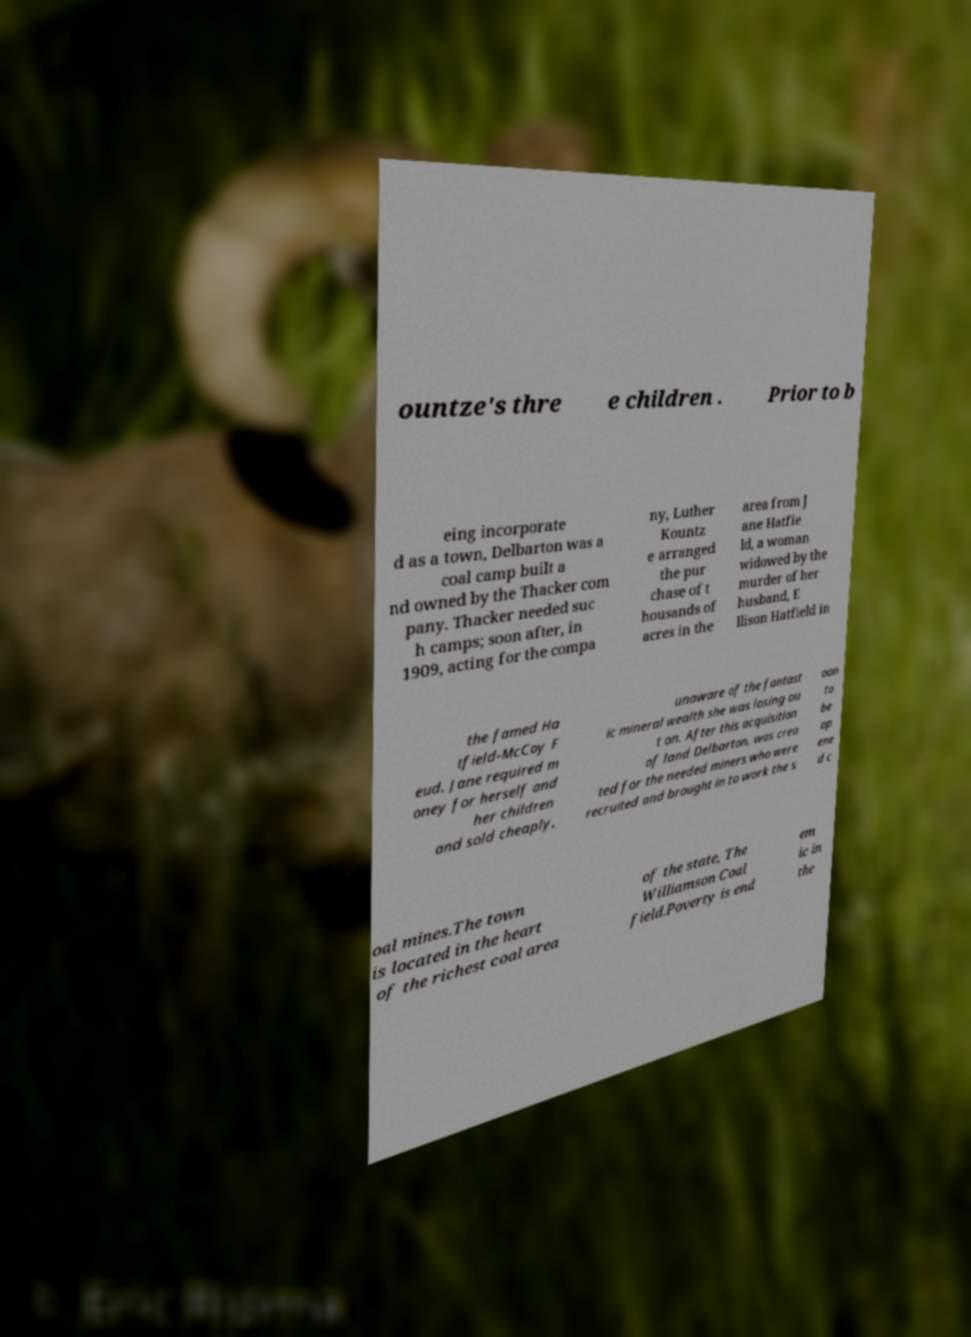Please identify and transcribe the text found in this image. ountze's thre e children . Prior to b eing incorporate d as a town, Delbarton was a coal camp built a nd owned by the Thacker com pany. Thacker needed suc h camps; soon after, in 1909, acting for the compa ny, Luther Kountz e arranged the pur chase of t housands of acres in the area from J ane Hatfie ld, a woman widowed by the murder of her husband, E llison Hatfield in the famed Ha tfield-McCoy F eud. Jane required m oney for herself and her children and sold cheaply, unaware of the fantast ic mineral wealth she was losing ou t on. After this acquisition of land Delbarton, was crea ted for the needed miners who were recruited and brought in to work the s oon to be op ene d c oal mines.The town is located in the heart of the richest coal area of the state, The Williamson Coal field.Poverty is end em ic in the 